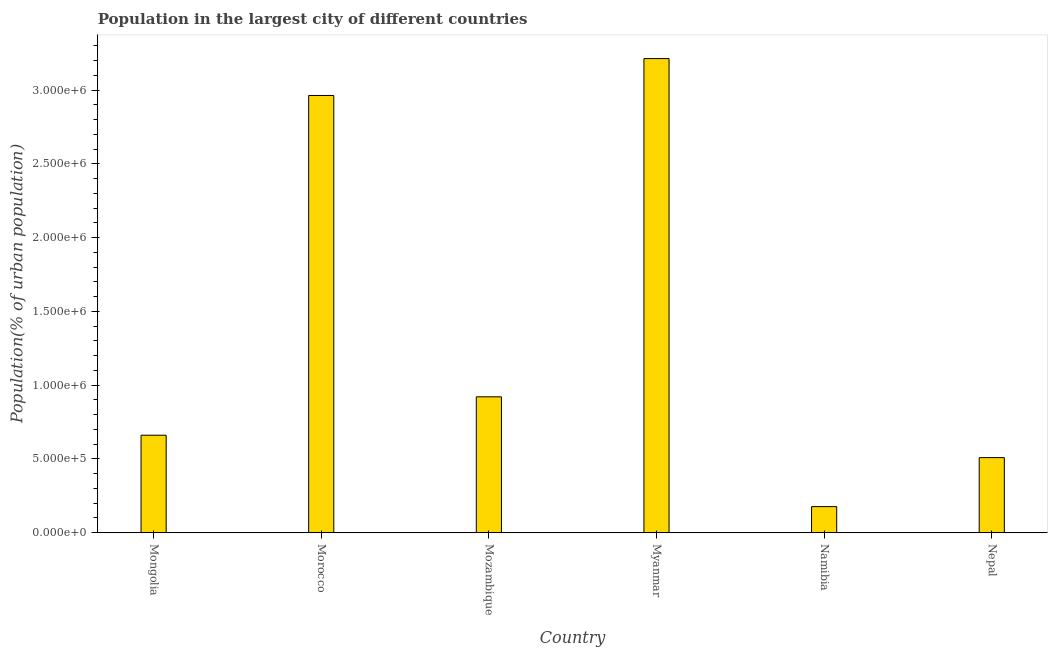Does the graph contain any zero values?
Provide a succinct answer. No. What is the title of the graph?
Give a very brief answer. Population in the largest city of different countries. What is the label or title of the Y-axis?
Ensure brevity in your answer.  Population(% of urban population). What is the population in largest city in Morocco?
Keep it short and to the point. 2.96e+06. Across all countries, what is the maximum population in largest city?
Provide a succinct answer. 3.21e+06. Across all countries, what is the minimum population in largest city?
Offer a terse response. 1.77e+05. In which country was the population in largest city maximum?
Make the answer very short. Myanmar. In which country was the population in largest city minimum?
Make the answer very short. Namibia. What is the sum of the population in largest city?
Offer a terse response. 8.44e+06. What is the difference between the population in largest city in Mongolia and Mozambique?
Keep it short and to the point. -2.60e+05. What is the average population in largest city per country?
Give a very brief answer. 1.41e+06. What is the median population in largest city?
Your answer should be very brief. 7.91e+05. In how many countries, is the population in largest city greater than 700000 %?
Offer a very short reply. 3. What is the ratio of the population in largest city in Mongolia to that in Nepal?
Your answer should be compact. 1.3. Is the population in largest city in Myanmar less than that in Namibia?
Offer a very short reply. No. What is the difference between the highest and the second highest population in largest city?
Keep it short and to the point. 2.50e+05. What is the difference between the highest and the lowest population in largest city?
Your answer should be compact. 3.04e+06. How many bars are there?
Your answer should be compact. 6. Are all the bars in the graph horizontal?
Ensure brevity in your answer.  No. How many countries are there in the graph?
Your response must be concise. 6. Are the values on the major ticks of Y-axis written in scientific E-notation?
Keep it short and to the point. Yes. What is the Population(% of urban population) in Mongolia?
Provide a short and direct response. 6.61e+05. What is the Population(% of urban population) in Morocco?
Ensure brevity in your answer.  2.96e+06. What is the Population(% of urban population) in Mozambique?
Provide a succinct answer. 9.21e+05. What is the Population(% of urban population) in Myanmar?
Make the answer very short. 3.21e+06. What is the Population(% of urban population) of Namibia?
Provide a short and direct response. 1.77e+05. What is the Population(% of urban population) in Nepal?
Ensure brevity in your answer.  5.09e+05. What is the difference between the Population(% of urban population) in Mongolia and Morocco?
Provide a succinct answer. -2.30e+06. What is the difference between the Population(% of urban population) in Mongolia and Mozambique?
Provide a short and direct response. -2.60e+05. What is the difference between the Population(% of urban population) in Mongolia and Myanmar?
Ensure brevity in your answer.  -2.55e+06. What is the difference between the Population(% of urban population) in Mongolia and Namibia?
Offer a terse response. 4.84e+05. What is the difference between the Population(% of urban population) in Mongolia and Nepal?
Give a very brief answer. 1.52e+05. What is the difference between the Population(% of urban population) in Morocco and Mozambique?
Your response must be concise. 2.04e+06. What is the difference between the Population(% of urban population) in Morocco and Myanmar?
Your answer should be compact. -2.50e+05. What is the difference between the Population(% of urban population) in Morocco and Namibia?
Offer a very short reply. 2.79e+06. What is the difference between the Population(% of urban population) in Morocco and Nepal?
Ensure brevity in your answer.  2.45e+06. What is the difference between the Population(% of urban population) in Mozambique and Myanmar?
Your response must be concise. -2.29e+06. What is the difference between the Population(% of urban population) in Mozambique and Namibia?
Your response must be concise. 7.44e+05. What is the difference between the Population(% of urban population) in Mozambique and Nepal?
Ensure brevity in your answer.  4.12e+05. What is the difference between the Population(% of urban population) in Myanmar and Namibia?
Give a very brief answer. 3.04e+06. What is the difference between the Population(% of urban population) in Myanmar and Nepal?
Give a very brief answer. 2.70e+06. What is the difference between the Population(% of urban population) in Namibia and Nepal?
Your answer should be very brief. -3.32e+05. What is the ratio of the Population(% of urban population) in Mongolia to that in Morocco?
Ensure brevity in your answer.  0.22. What is the ratio of the Population(% of urban population) in Mongolia to that in Mozambique?
Ensure brevity in your answer.  0.72. What is the ratio of the Population(% of urban population) in Mongolia to that in Myanmar?
Your answer should be compact. 0.21. What is the ratio of the Population(% of urban population) in Mongolia to that in Namibia?
Provide a short and direct response. 3.74. What is the ratio of the Population(% of urban population) in Mongolia to that in Nepal?
Ensure brevity in your answer.  1.3. What is the ratio of the Population(% of urban population) in Morocco to that in Mozambique?
Your answer should be very brief. 3.22. What is the ratio of the Population(% of urban population) in Morocco to that in Myanmar?
Your answer should be compact. 0.92. What is the ratio of the Population(% of urban population) in Morocco to that in Namibia?
Your response must be concise. 16.76. What is the ratio of the Population(% of urban population) in Morocco to that in Nepal?
Offer a terse response. 5.82. What is the ratio of the Population(% of urban population) in Mozambique to that in Myanmar?
Your answer should be very brief. 0.29. What is the ratio of the Population(% of urban population) in Mozambique to that in Namibia?
Keep it short and to the point. 5.21. What is the ratio of the Population(% of urban population) in Mozambique to that in Nepal?
Your response must be concise. 1.81. What is the ratio of the Population(% of urban population) in Myanmar to that in Namibia?
Offer a terse response. 18.17. What is the ratio of the Population(% of urban population) in Myanmar to that in Nepal?
Give a very brief answer. 6.31. What is the ratio of the Population(% of urban population) in Namibia to that in Nepal?
Make the answer very short. 0.35. 